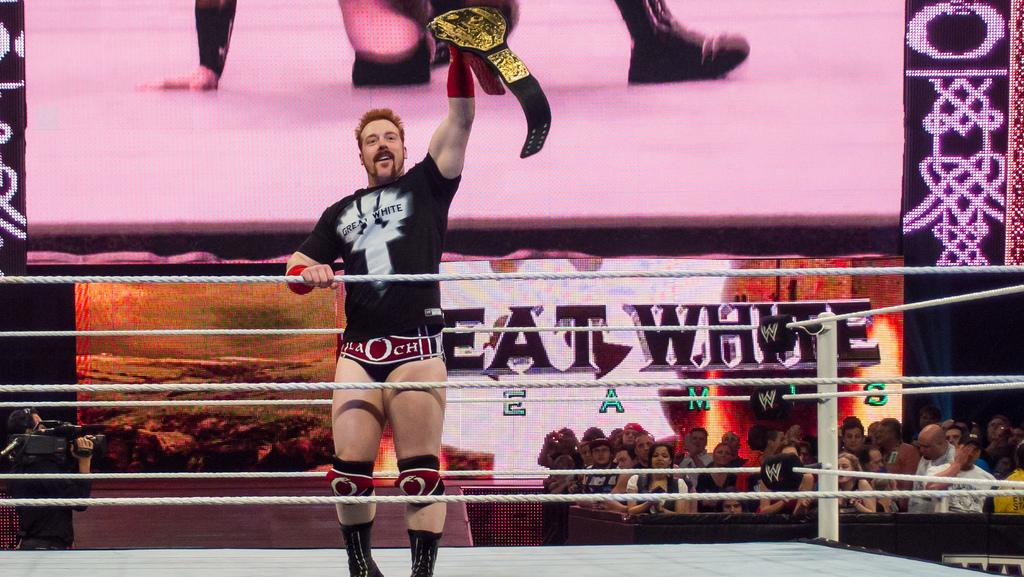<image>
Relay a brief, clear account of the picture shown. A wrestler holds his winning belt aloft in front of a "Great White" banner. 